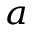<formula> <loc_0><loc_0><loc_500><loc_500>_ { a }</formula> 